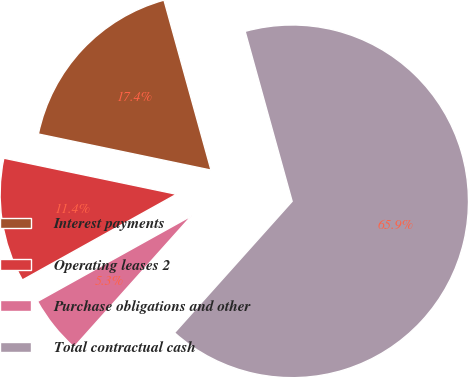<chart> <loc_0><loc_0><loc_500><loc_500><pie_chart><fcel>Interest payments<fcel>Operating leases 2<fcel>Purchase obligations and other<fcel>Total contractual cash<nl><fcel>17.42%<fcel>11.36%<fcel>5.3%<fcel>65.91%<nl></chart> 